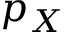<formula> <loc_0><loc_0><loc_500><loc_500>p _ { X }</formula> 